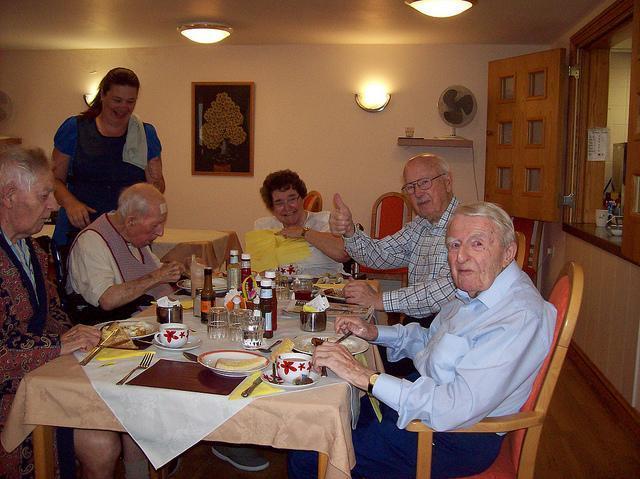How many squares are on the door by the fan?
Give a very brief answer. 6. How many people are standing?
Give a very brief answer. 1. How many people are in the photo?
Give a very brief answer. 6. How many dining tables can you see?
Give a very brief answer. 2. How many of the frisbees are in the air?
Give a very brief answer. 0. 